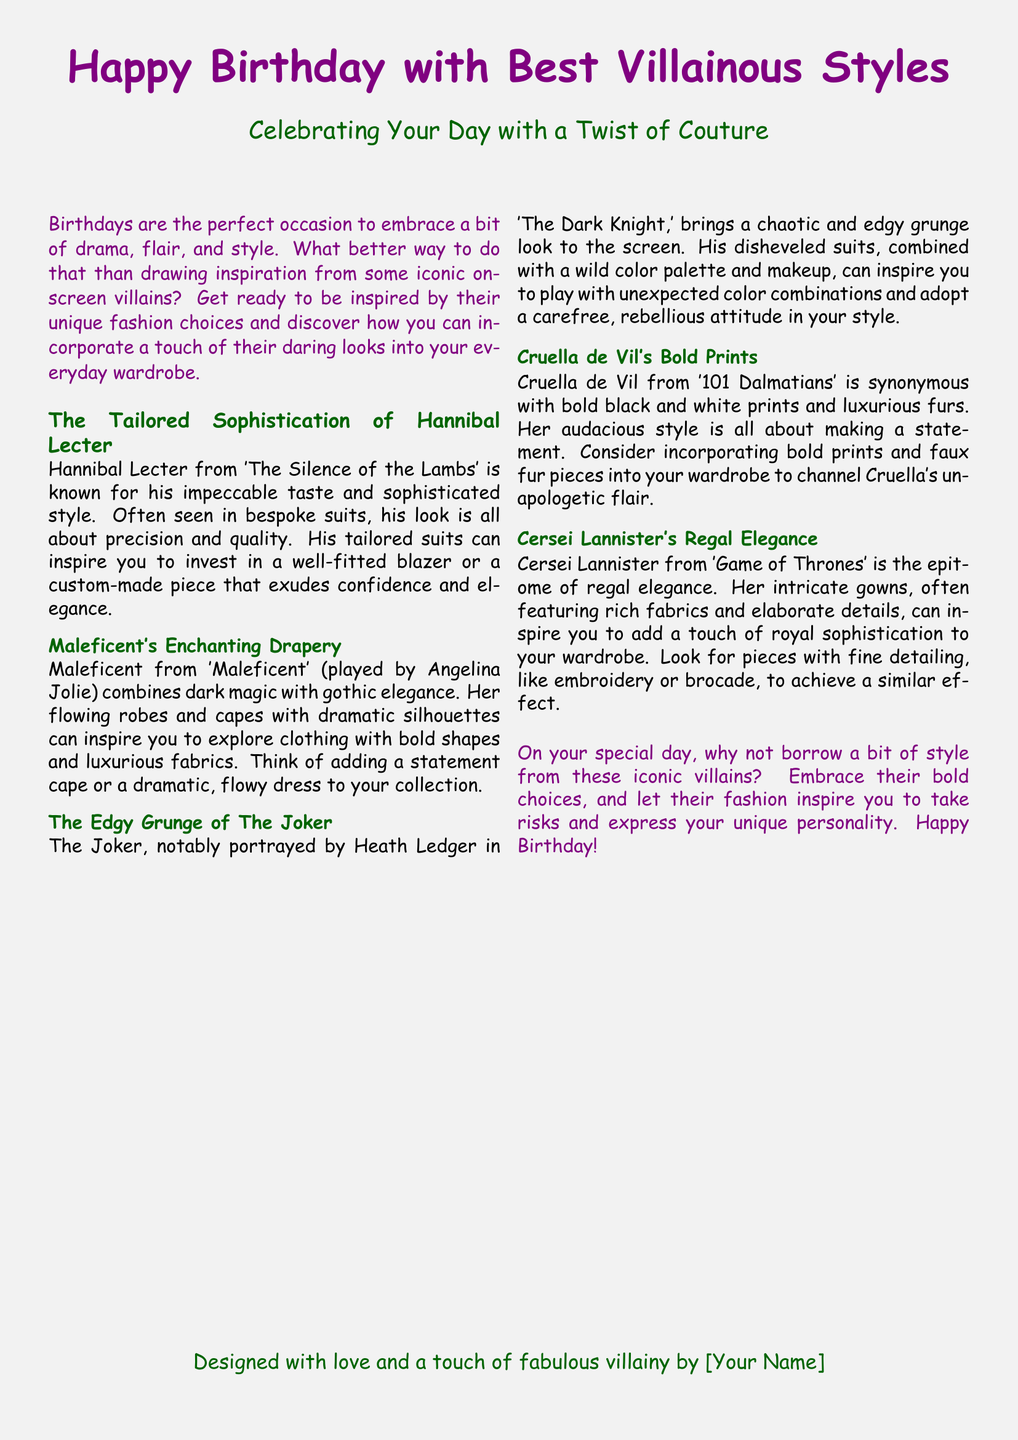What is the title of the greeting card? The title of the greeting card is prominently displayed at the top, saying "Happy Birthday with Best Villainous Styles."
Answer: Happy Birthday with Best Villainous Styles Who is celebrated in this card? The card is designed to celebrate the recipient's birthday, indicated by the phrase "Happy Birthday."
Answer: Birthday What character is associated with tailored sophistication? The document mentions Hannibal Lecter as the character known for tailored sophistication.
Answer: Hannibal Lecter Which character embodies gothic elegance? Maleficent is described as combining dark magic with gothic elegance in the document.
Answer: Maleficent What type of prints is Cruella de Vil known for? The document states that Cruella de Vil is synonymous with bold black and white prints.
Answer: Bold black and white prints What is suggested to channel Cruella's style? The card suggests incorporating bold prints and faux fur pieces into your wardrobe.
Answer: Bold prints and faux fur How does the card suggest you should feel about borrowing style from villains? The card encourages readers to embrace their bold choices and take risks.
Answer: Embrace bold choices What unique feature does Cersei Lannister's style include? Cersei Lannister's style is characterized by intricate gowns featuring rich fabrics and elaborate details.
Answer: Intricate gowns What is the color scheme of the greeting card? The document uses villain purple and villain green for its color scheme.
Answer: Villain purple and villain green 